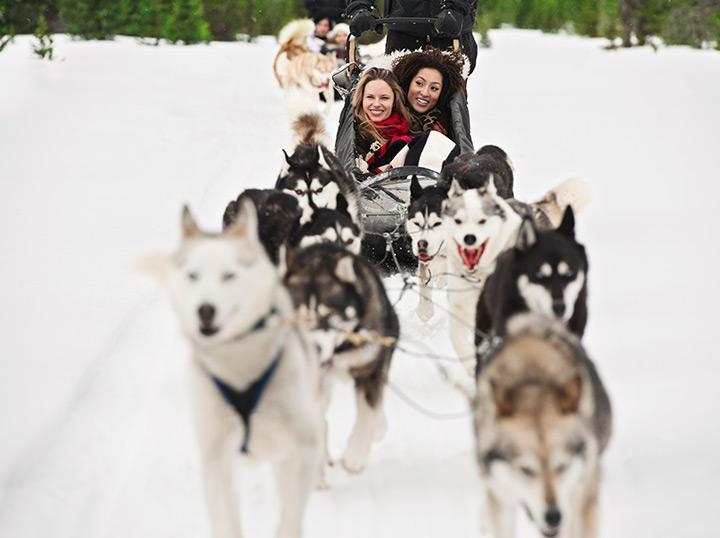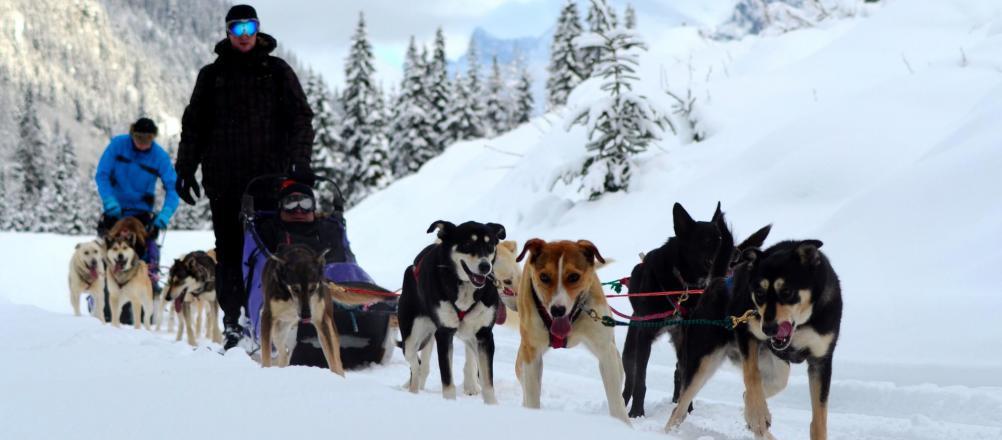The first image is the image on the left, the second image is the image on the right. Evaluate the accuracy of this statement regarding the images: "There is at least one sled dog team pulling people on dog sleds through the snow.". Is it true? Answer yes or no. Yes. The first image is the image on the left, the second image is the image on the right. Given the left and right images, does the statement "In the left image, one of the lead dogs is white." hold true? Answer yes or no. Yes. 